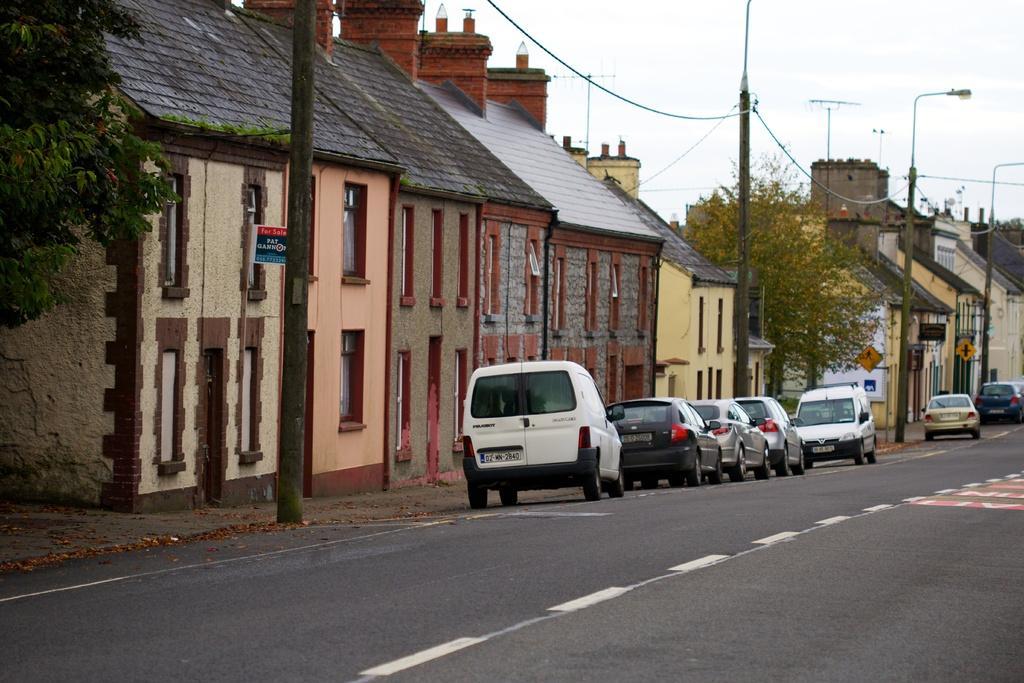Could you give a brief overview of what you see in this image? These are the cars, which are parked on the road. I can see the houses with the windows. I think these are the current poles with the current wires. This looks like a street light. These are the trees. I can see the sign boards. Here is the sky. 